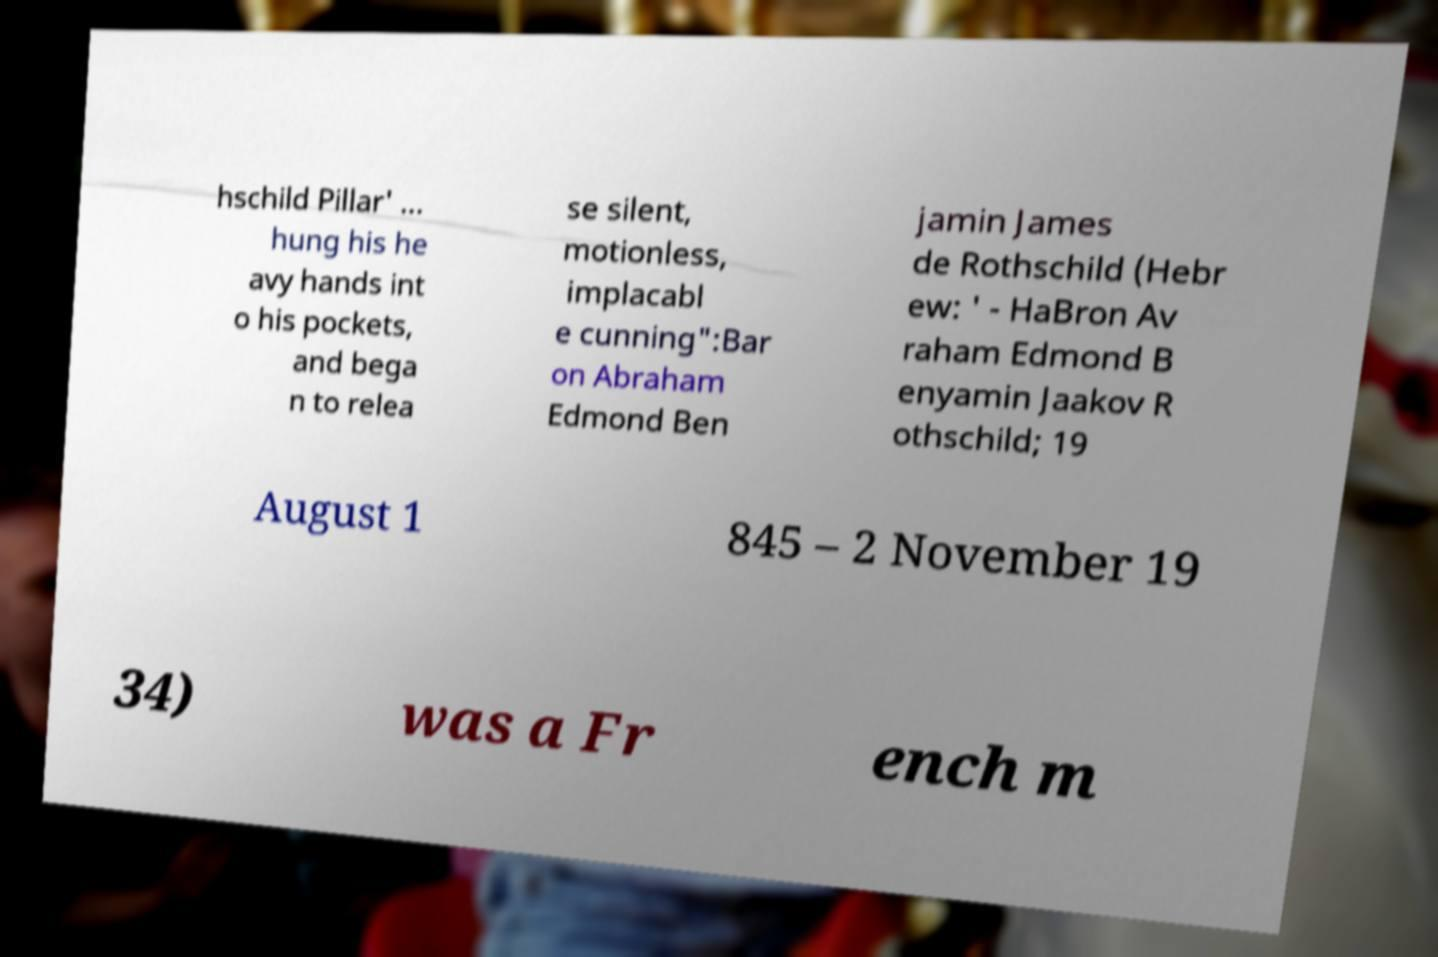Could you assist in decoding the text presented in this image and type it out clearly? hschild Pillar' ... hung his he avy hands int o his pockets, and bega n to relea se silent, motionless, implacabl e cunning":Bar on Abraham Edmond Ben jamin James de Rothschild (Hebr ew: ' - HaBron Av raham Edmond B enyamin Jaakov R othschild; 19 August 1 845 – 2 November 19 34) was a Fr ench m 